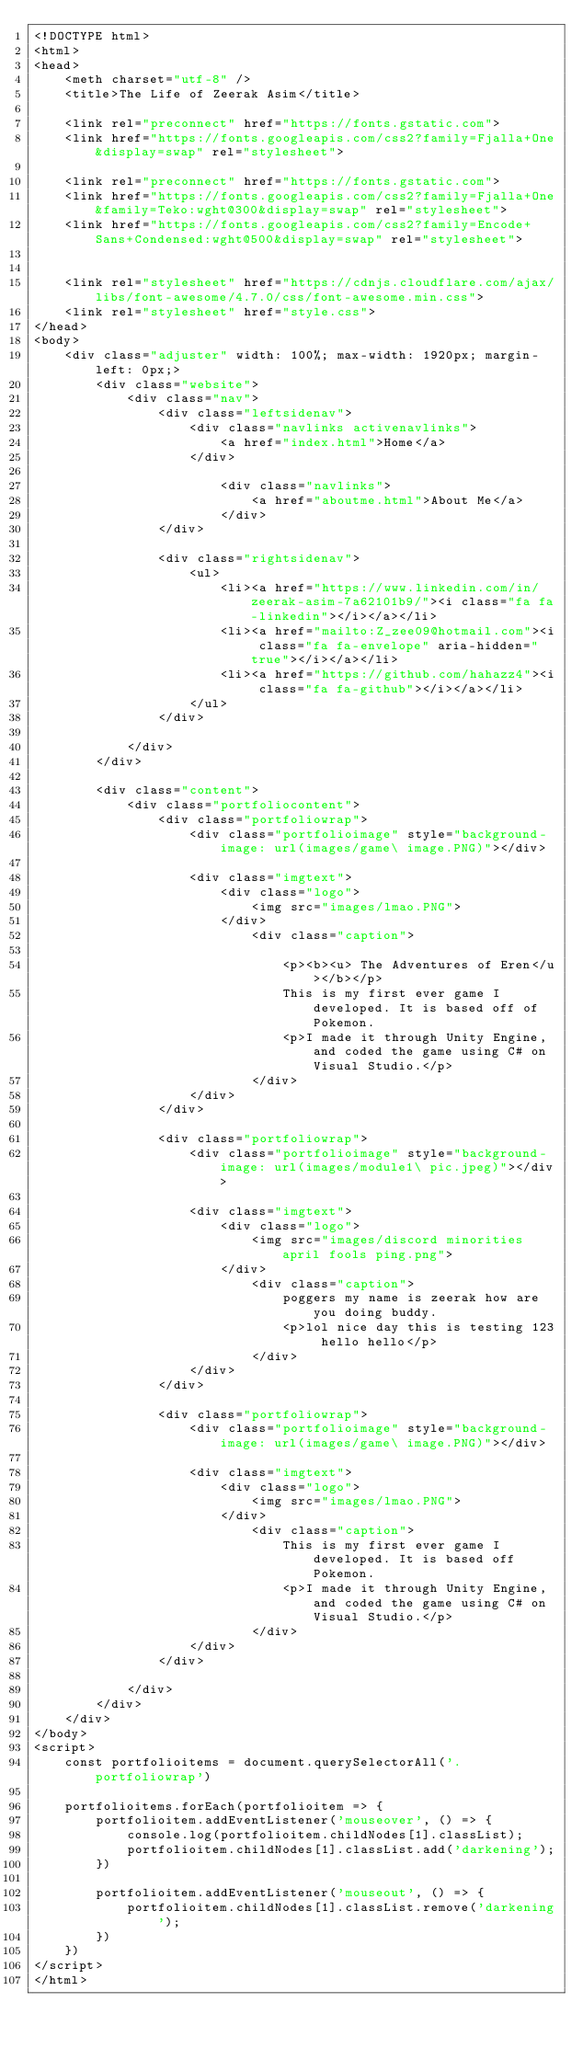<code> <loc_0><loc_0><loc_500><loc_500><_HTML_><!DOCTYPE html>
<html>
<head>
    <meth charset="utf-8" />
    <title>The Life of Zeerak Asim</title>
    
    <link rel="preconnect" href="https://fonts.gstatic.com">
    <link href="https://fonts.googleapis.com/css2?family=Fjalla+One&display=swap" rel="stylesheet">

    <link rel="preconnect" href="https://fonts.gstatic.com">
    <link href="https://fonts.googleapis.com/css2?family=Fjalla+One&family=Teko:wght@300&display=swap" rel="stylesheet">
    <link href="https://fonts.googleapis.com/css2?family=Encode+Sans+Condensed:wght@500&display=swap" rel="stylesheet">


    <link rel="stylesheet" href="https://cdnjs.cloudflare.com/ajax/libs/font-awesome/4.7.0/css/font-awesome.min.css">
    <link rel="stylesheet" href="style.css">
</head>
<body>
    <div class="adjuster" width: 100%; max-width: 1920px; margin-left: 0px;>
        <div class="website">
            <div class="nav">
                <div class="leftsidenav">
                    <div class="navlinks activenavlinks">    
                        <a href="index.html">Home</a>
                    </div>            

                        <div class="navlinks">
                            <a href="aboutme.html">About Me</a>
                        </div>                
                </div>  

                <div class="rightsidenav">
                    <ul>
                        <li><a href="https://www.linkedin.com/in/zeerak-asim-7a62101b9/"><i class="fa fa-linkedin"></i></a></li>
                        <li><a href="mailto:Z_zee09@hotmail.com"><i class="fa fa-envelope" aria-hidden="true"></i></a></li>
                        <li><a href="https://github.com/hahazz4"><i class="fa fa-github"></i></a></li>
                    </ul>
                </div>
 
            </div>   
        </div>

        <div class="content">
            <div class="portfoliocontent">
                <div class="portfoliowrap">
                    <div class="portfolioimage" style="background-image: url(images/game\ image.PNG)"></div>               
            
                    <div class="imgtext">
                        <div class="logo">
                            <img src="images/lmao.PNG"> 
                        </div>
                            <div class="caption">
                                
                                <p><b><u> The Adventures of Eren</u></b></p>
                                This is my first ever game I developed. It is based off of Pokemon. 
                                <p>I made it through Unity Engine, and coded the game using C# on Visual Studio.</p>
                            </div>
                    </div>
                </div> 
                
                <div class="portfoliowrap">
                    <div class="portfolioimage" style="background-image: url(images/module1\ pic.jpeg)"></div>               
            
                    <div class="imgtext">
                        <div class="logo">
                            <img src="images/discord minorities april fools ping.png">
                        </div>
                            <div class="caption">
                                poggers my name is zeerak how are you doing buddy.
                                <p>lol nice day this is testing 123 hello hello</p> 
                            </div>
                    </div>
                </div>

                <div class="portfoliowrap">
                    <div class="portfolioimage" style="background-image: url(images/game\ image.PNG)"></div>               
            
                    <div class="imgtext">
                        <div class="logo">
                            <img src="images/lmao.PNG"> 
                        </div>
                            <div class="caption">
                                This is my first ever game I developed. It is based off Pokemon. 
                                <p>I made it through Unity Engine, and coded the game using C# on Visual Studio.</p>
                            </div>
                    </div>
                </div> 
            
            </div>
        </div>
    </div>    
</body>
<script>
    const portfolioitems = document.querySelectorAll('.portfoliowrap')

    portfolioitems.forEach(portfolioitem => {
        portfolioitem.addEventListener('mouseover', () => {
            console.log(portfolioitem.childNodes[1].classList);
            portfolioitem.childNodes[1].classList.add('darkening');
        })

        portfolioitem.addEventListener('mouseout', () => {
            portfolioitem.childNodes[1].classList.remove('darkening');
        })
    })    
</script>
</html></code> 